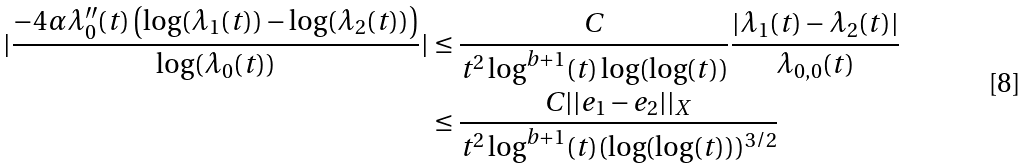Convert formula to latex. <formula><loc_0><loc_0><loc_500><loc_500>| \frac { - 4 \alpha \lambda _ { 0 } ^ { \prime \prime } ( t ) \left ( \log ( \lambda _ { 1 } ( t ) ) - \log ( \lambda _ { 2 } ( t ) ) \right ) } { \log ( \lambda _ { 0 } ( t ) ) } | & \leq \frac { C } { t ^ { 2 } \log ^ { b + 1 } ( t ) \log ( \log ( t ) ) } \frac { | \lambda _ { 1 } ( t ) - \lambda _ { 2 } ( t ) | } { \lambda _ { 0 , 0 } ( t ) } \\ & \leq \frac { C | | e _ { 1 } - e _ { 2 } | | _ { X } } { t ^ { 2 } \log ^ { b + 1 } ( t ) ( \log ( \log ( t ) ) ) ^ { 3 / 2 } }</formula> 